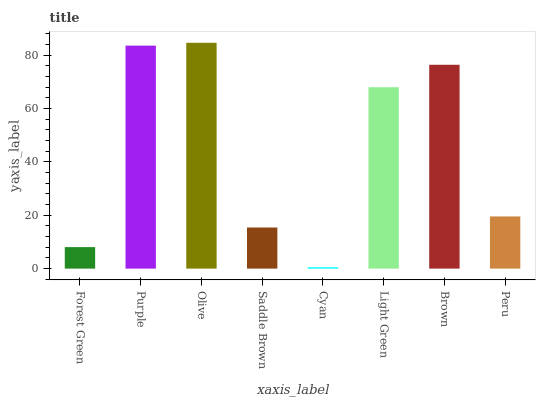Is Cyan the minimum?
Answer yes or no. Yes. Is Olive the maximum?
Answer yes or no. Yes. Is Purple the minimum?
Answer yes or no. No. Is Purple the maximum?
Answer yes or no. No. Is Purple greater than Forest Green?
Answer yes or no. Yes. Is Forest Green less than Purple?
Answer yes or no. Yes. Is Forest Green greater than Purple?
Answer yes or no. No. Is Purple less than Forest Green?
Answer yes or no. No. Is Light Green the high median?
Answer yes or no. Yes. Is Peru the low median?
Answer yes or no. Yes. Is Peru the high median?
Answer yes or no. No. Is Light Green the low median?
Answer yes or no. No. 